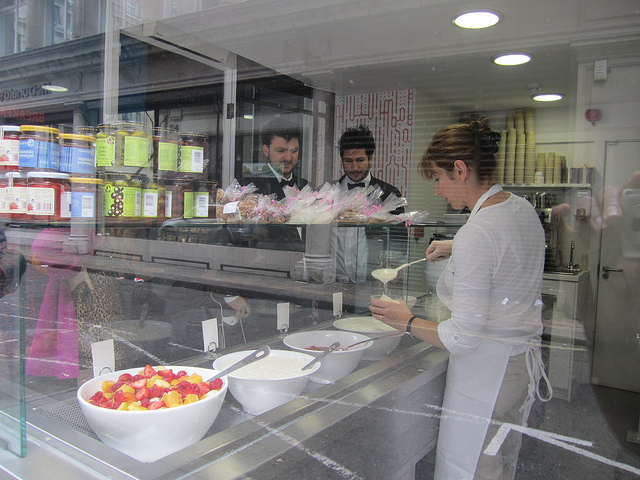<image>What kind of print is on the uniform pants? I am not sure. The print on the uniform pants might be solid or plain. What kind of print is on the uniform pants? There is no print on the uniform pants. 